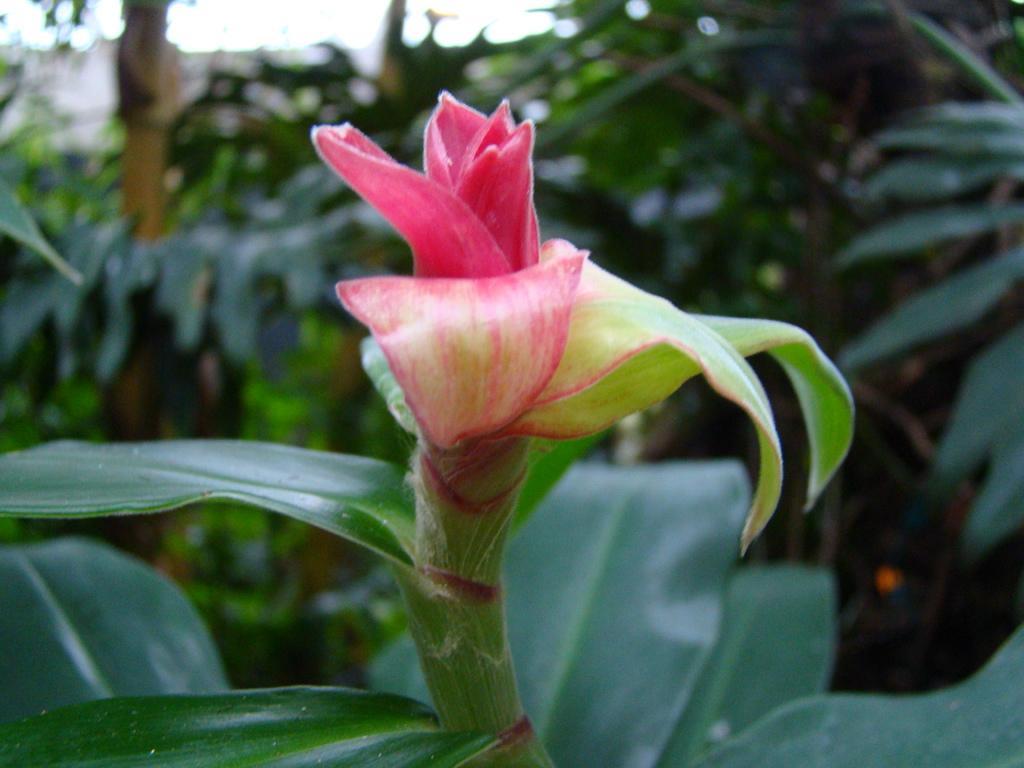How would you summarize this image in a sentence or two? In this image there is a bud to a stem. Behind it there are plants. At the top there is the sky. 